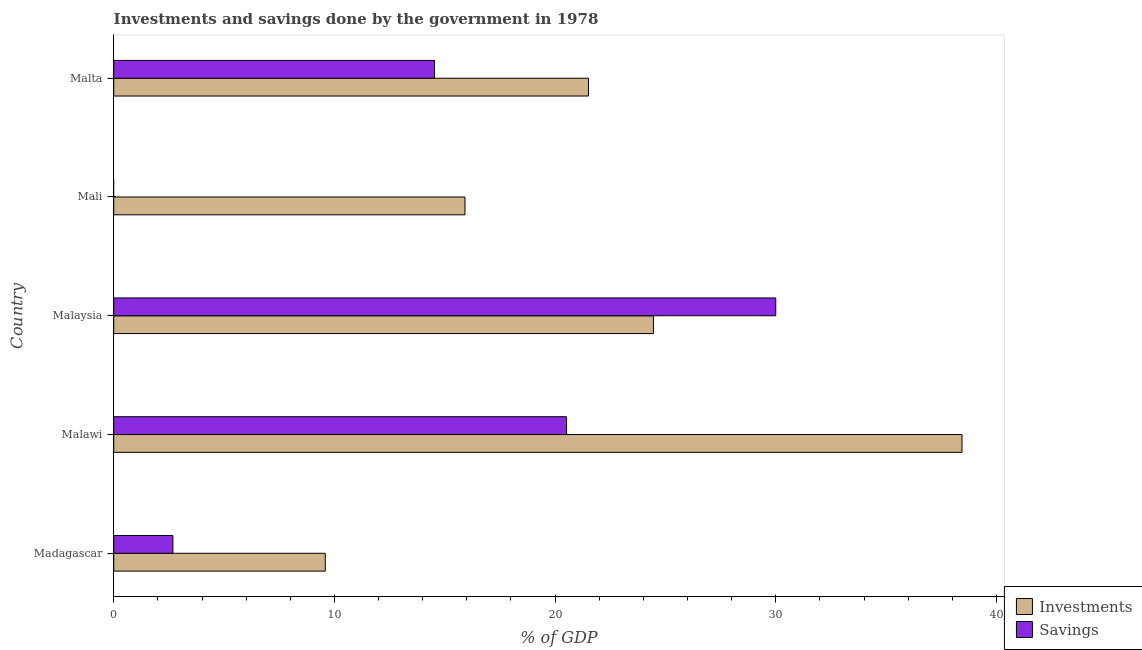Are the number of bars on each tick of the Y-axis equal?
Make the answer very short. No. How many bars are there on the 5th tick from the top?
Keep it short and to the point. 2. How many bars are there on the 1st tick from the bottom?
Offer a terse response. 2. What is the label of the 1st group of bars from the top?
Provide a succinct answer. Malta. What is the investments of government in Malta?
Provide a short and direct response. 21.51. Across all countries, what is the maximum investments of government?
Give a very brief answer. 38.44. Across all countries, what is the minimum savings of government?
Offer a terse response. 0. In which country was the investments of government maximum?
Your answer should be compact. Malawi. What is the total savings of government in the graph?
Offer a terse response. 67.74. What is the difference between the investments of government in Mali and that in Malta?
Offer a terse response. -5.6. What is the difference between the investments of government in Malaysia and the savings of government in Malta?
Provide a short and direct response. 9.92. What is the average savings of government per country?
Your answer should be very brief. 13.55. What is the difference between the investments of government and savings of government in Malawi?
Your response must be concise. 17.92. In how many countries, is the savings of government greater than 18 %?
Provide a succinct answer. 2. What is the ratio of the savings of government in Madagascar to that in Malta?
Ensure brevity in your answer.  0.18. What is the difference between the highest and the second highest investments of government?
Provide a succinct answer. 13.98. In how many countries, is the savings of government greater than the average savings of government taken over all countries?
Provide a succinct answer. 3. How many countries are there in the graph?
Make the answer very short. 5. Are the values on the major ticks of X-axis written in scientific E-notation?
Offer a very short reply. No. Does the graph contain grids?
Your answer should be very brief. No. Where does the legend appear in the graph?
Make the answer very short. Bottom right. What is the title of the graph?
Your response must be concise. Investments and savings done by the government in 1978. What is the label or title of the X-axis?
Your answer should be very brief. % of GDP. What is the % of GDP in Investments in Madagascar?
Your response must be concise. 9.59. What is the % of GDP of Savings in Madagascar?
Make the answer very short. 2.68. What is the % of GDP of Investments in Malawi?
Offer a very short reply. 38.44. What is the % of GDP of Savings in Malawi?
Ensure brevity in your answer.  20.52. What is the % of GDP of Investments in Malaysia?
Your answer should be compact. 24.46. What is the % of GDP in Savings in Malaysia?
Offer a terse response. 30. What is the % of GDP in Investments in Mali?
Provide a short and direct response. 15.92. What is the % of GDP in Investments in Malta?
Make the answer very short. 21.51. What is the % of GDP in Savings in Malta?
Your response must be concise. 14.54. Across all countries, what is the maximum % of GDP of Investments?
Give a very brief answer. 38.44. Across all countries, what is the maximum % of GDP of Savings?
Your answer should be very brief. 30. Across all countries, what is the minimum % of GDP of Investments?
Offer a terse response. 9.59. What is the total % of GDP of Investments in the graph?
Ensure brevity in your answer.  109.92. What is the total % of GDP of Savings in the graph?
Keep it short and to the point. 67.74. What is the difference between the % of GDP of Investments in Madagascar and that in Malawi?
Keep it short and to the point. -28.85. What is the difference between the % of GDP in Savings in Madagascar and that in Malawi?
Make the answer very short. -17.84. What is the difference between the % of GDP of Investments in Madagascar and that in Malaysia?
Give a very brief answer. -14.87. What is the difference between the % of GDP of Savings in Madagascar and that in Malaysia?
Provide a short and direct response. -27.32. What is the difference between the % of GDP in Investments in Madagascar and that in Mali?
Keep it short and to the point. -6.33. What is the difference between the % of GDP in Investments in Madagascar and that in Malta?
Make the answer very short. -11.93. What is the difference between the % of GDP of Savings in Madagascar and that in Malta?
Provide a short and direct response. -11.86. What is the difference between the % of GDP in Investments in Malawi and that in Malaysia?
Ensure brevity in your answer.  13.98. What is the difference between the % of GDP of Savings in Malawi and that in Malaysia?
Provide a succinct answer. -9.48. What is the difference between the % of GDP in Investments in Malawi and that in Mali?
Your response must be concise. 22.52. What is the difference between the % of GDP of Investments in Malawi and that in Malta?
Your answer should be compact. 16.93. What is the difference between the % of GDP of Savings in Malawi and that in Malta?
Offer a very short reply. 5.98. What is the difference between the % of GDP of Investments in Malaysia and that in Mali?
Ensure brevity in your answer.  8.54. What is the difference between the % of GDP in Investments in Malaysia and that in Malta?
Provide a succinct answer. 2.94. What is the difference between the % of GDP of Savings in Malaysia and that in Malta?
Provide a succinct answer. 15.46. What is the difference between the % of GDP in Investments in Mali and that in Malta?
Your response must be concise. -5.6. What is the difference between the % of GDP in Investments in Madagascar and the % of GDP in Savings in Malawi?
Your answer should be compact. -10.93. What is the difference between the % of GDP of Investments in Madagascar and the % of GDP of Savings in Malaysia?
Give a very brief answer. -20.41. What is the difference between the % of GDP of Investments in Madagascar and the % of GDP of Savings in Malta?
Your answer should be very brief. -4.95. What is the difference between the % of GDP of Investments in Malawi and the % of GDP of Savings in Malaysia?
Your answer should be very brief. 8.44. What is the difference between the % of GDP of Investments in Malawi and the % of GDP of Savings in Malta?
Offer a very short reply. 23.91. What is the difference between the % of GDP of Investments in Malaysia and the % of GDP of Savings in Malta?
Your answer should be compact. 9.92. What is the difference between the % of GDP in Investments in Mali and the % of GDP in Savings in Malta?
Offer a terse response. 1.38. What is the average % of GDP in Investments per country?
Offer a terse response. 21.98. What is the average % of GDP of Savings per country?
Make the answer very short. 13.55. What is the difference between the % of GDP of Investments and % of GDP of Savings in Madagascar?
Offer a very short reply. 6.91. What is the difference between the % of GDP of Investments and % of GDP of Savings in Malawi?
Your answer should be very brief. 17.92. What is the difference between the % of GDP in Investments and % of GDP in Savings in Malaysia?
Offer a terse response. -5.54. What is the difference between the % of GDP of Investments and % of GDP of Savings in Malta?
Your response must be concise. 6.98. What is the ratio of the % of GDP in Investments in Madagascar to that in Malawi?
Offer a very short reply. 0.25. What is the ratio of the % of GDP of Savings in Madagascar to that in Malawi?
Provide a succinct answer. 0.13. What is the ratio of the % of GDP of Investments in Madagascar to that in Malaysia?
Make the answer very short. 0.39. What is the ratio of the % of GDP in Savings in Madagascar to that in Malaysia?
Provide a short and direct response. 0.09. What is the ratio of the % of GDP in Investments in Madagascar to that in Mali?
Provide a succinct answer. 0.6. What is the ratio of the % of GDP of Investments in Madagascar to that in Malta?
Ensure brevity in your answer.  0.45. What is the ratio of the % of GDP of Savings in Madagascar to that in Malta?
Provide a succinct answer. 0.18. What is the ratio of the % of GDP of Investments in Malawi to that in Malaysia?
Your answer should be very brief. 1.57. What is the ratio of the % of GDP in Savings in Malawi to that in Malaysia?
Your answer should be compact. 0.68. What is the ratio of the % of GDP of Investments in Malawi to that in Mali?
Your response must be concise. 2.42. What is the ratio of the % of GDP of Investments in Malawi to that in Malta?
Make the answer very short. 1.79. What is the ratio of the % of GDP in Savings in Malawi to that in Malta?
Provide a succinct answer. 1.41. What is the ratio of the % of GDP in Investments in Malaysia to that in Mali?
Keep it short and to the point. 1.54. What is the ratio of the % of GDP of Investments in Malaysia to that in Malta?
Offer a very short reply. 1.14. What is the ratio of the % of GDP of Savings in Malaysia to that in Malta?
Offer a terse response. 2.06. What is the ratio of the % of GDP in Investments in Mali to that in Malta?
Your response must be concise. 0.74. What is the difference between the highest and the second highest % of GDP in Investments?
Your answer should be very brief. 13.98. What is the difference between the highest and the second highest % of GDP of Savings?
Give a very brief answer. 9.48. What is the difference between the highest and the lowest % of GDP of Investments?
Offer a terse response. 28.85. What is the difference between the highest and the lowest % of GDP in Savings?
Keep it short and to the point. 30. 